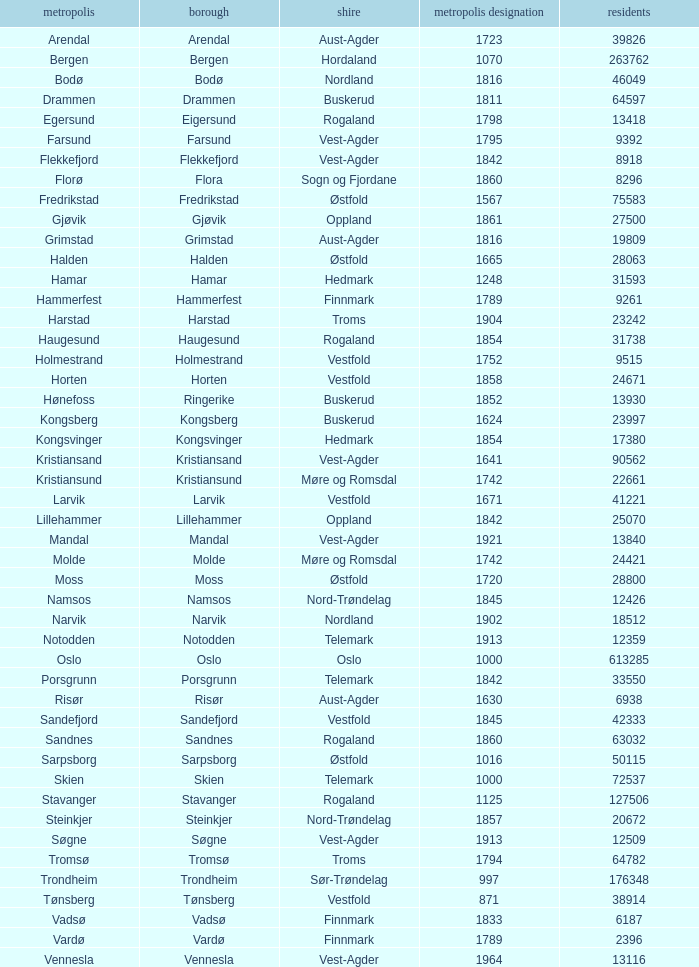What are the cities/towns located in the municipality of Moss? Moss. 